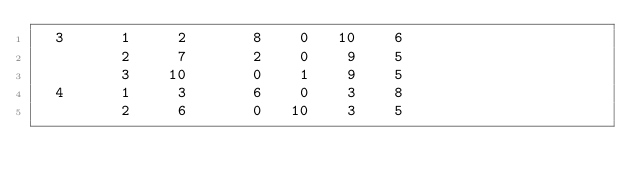Convert code to text. <code><loc_0><loc_0><loc_500><loc_500><_ObjectiveC_>  3      1     2       8    0   10    6
         2     7       2    0    9    5
         3    10       0    1    9    5
  4      1     3       6    0    3    8
         2     6       0   10    3    5</code> 